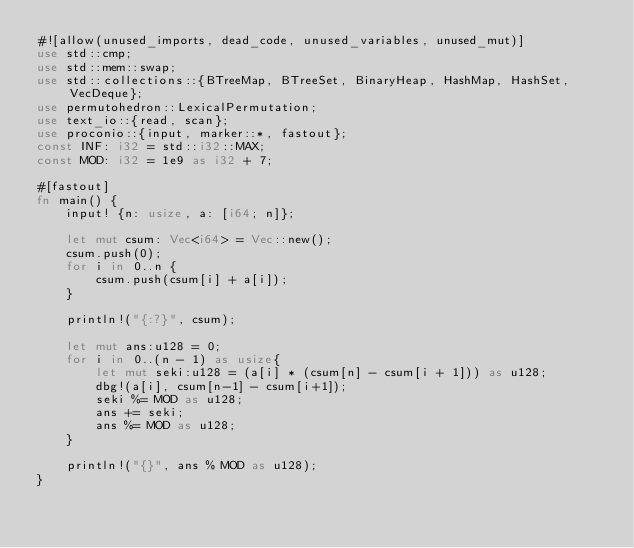<code> <loc_0><loc_0><loc_500><loc_500><_Rust_>#![allow(unused_imports, dead_code, unused_variables, unused_mut)]
use std::cmp;
use std::mem::swap;
use std::collections::{BTreeMap, BTreeSet, BinaryHeap, HashMap, HashSet, VecDeque};
use permutohedron::LexicalPermutation;
use text_io::{read, scan};
use proconio::{input, marker::*, fastout};
const INF: i32 = std::i32::MAX;
const MOD: i32 = 1e9 as i32 + 7;

#[fastout]
fn main() {
    input! {n: usize, a: [i64; n]};

    let mut csum: Vec<i64> = Vec::new();
    csum.push(0);
    for i in 0..n {
        csum.push(csum[i] + a[i]);
    }

    println!("{:?}", csum);

    let mut ans:u128 = 0;
    for i in 0..(n - 1) as usize{
        let mut seki:u128 = (a[i] * (csum[n] - csum[i + 1])) as u128;
        dbg!(a[i], csum[n-1] - csum[i+1]);
        seki %= MOD as u128; 
        ans += seki;
        ans %= MOD as u128;
    }

    println!("{}", ans % MOD as u128);
}</code> 